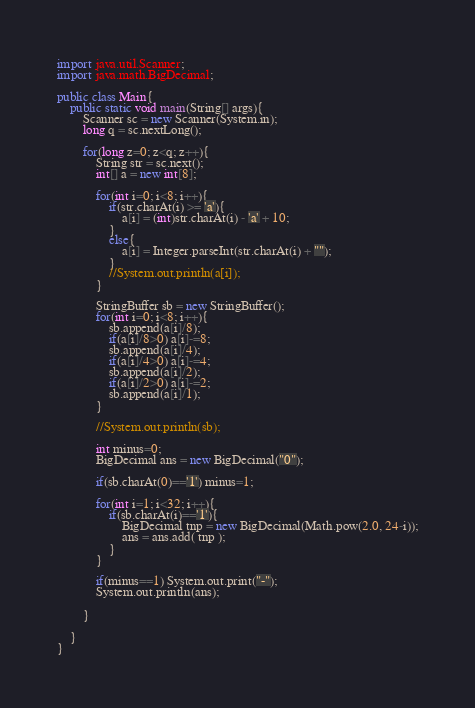<code> <loc_0><loc_0><loc_500><loc_500><_Java_>import java.util.Scanner;
import java.math.BigDecimal;

public class Main{
	public static void main(String[] args){
		Scanner sc = new Scanner(System.in);
		long q = sc.nextLong();
		
		for(long z=0; z<q; z++){
			String str = sc.next();
			int[] a = new int[8];
		
			for(int i=0; i<8; i++){
				if(str.charAt(i) >= 'a'){
					a[i] = (int)str.charAt(i) - 'a' + 10;
				}
				else{
					a[i] = Integer.parseInt(str.charAt(i) + "");
				}
				//System.out.println(a[i]);
			}
		
			StringBuffer sb = new StringBuffer();
			for(int i=0; i<8; i++){
				sb.append(a[i]/8);
				if(a[i]/8>0) a[i]-=8;
				sb.append(a[i]/4);
				if(a[i]/4>0) a[i]-=4;
				sb.append(a[i]/2);
				if(a[i]/2>0) a[i]-=2;
				sb.append(a[i]/1);
			}			
		
			//System.out.println(sb);
			
			int minus=0;
			BigDecimal ans = new BigDecimal("0");
			
			if(sb.charAt(0)=='1') minus=1;
			
			for(int i=1; i<32; i++){
				if(sb.charAt(i)=='1'){
					BigDecimal tnp = new BigDecimal(Math.pow(2.0, 24-i));
					ans = ans.add( tnp );
				}
			}
			
			if(minus==1) System.out.print("-");
			System.out.println(ans);
	
		}
	
	}
}</code> 